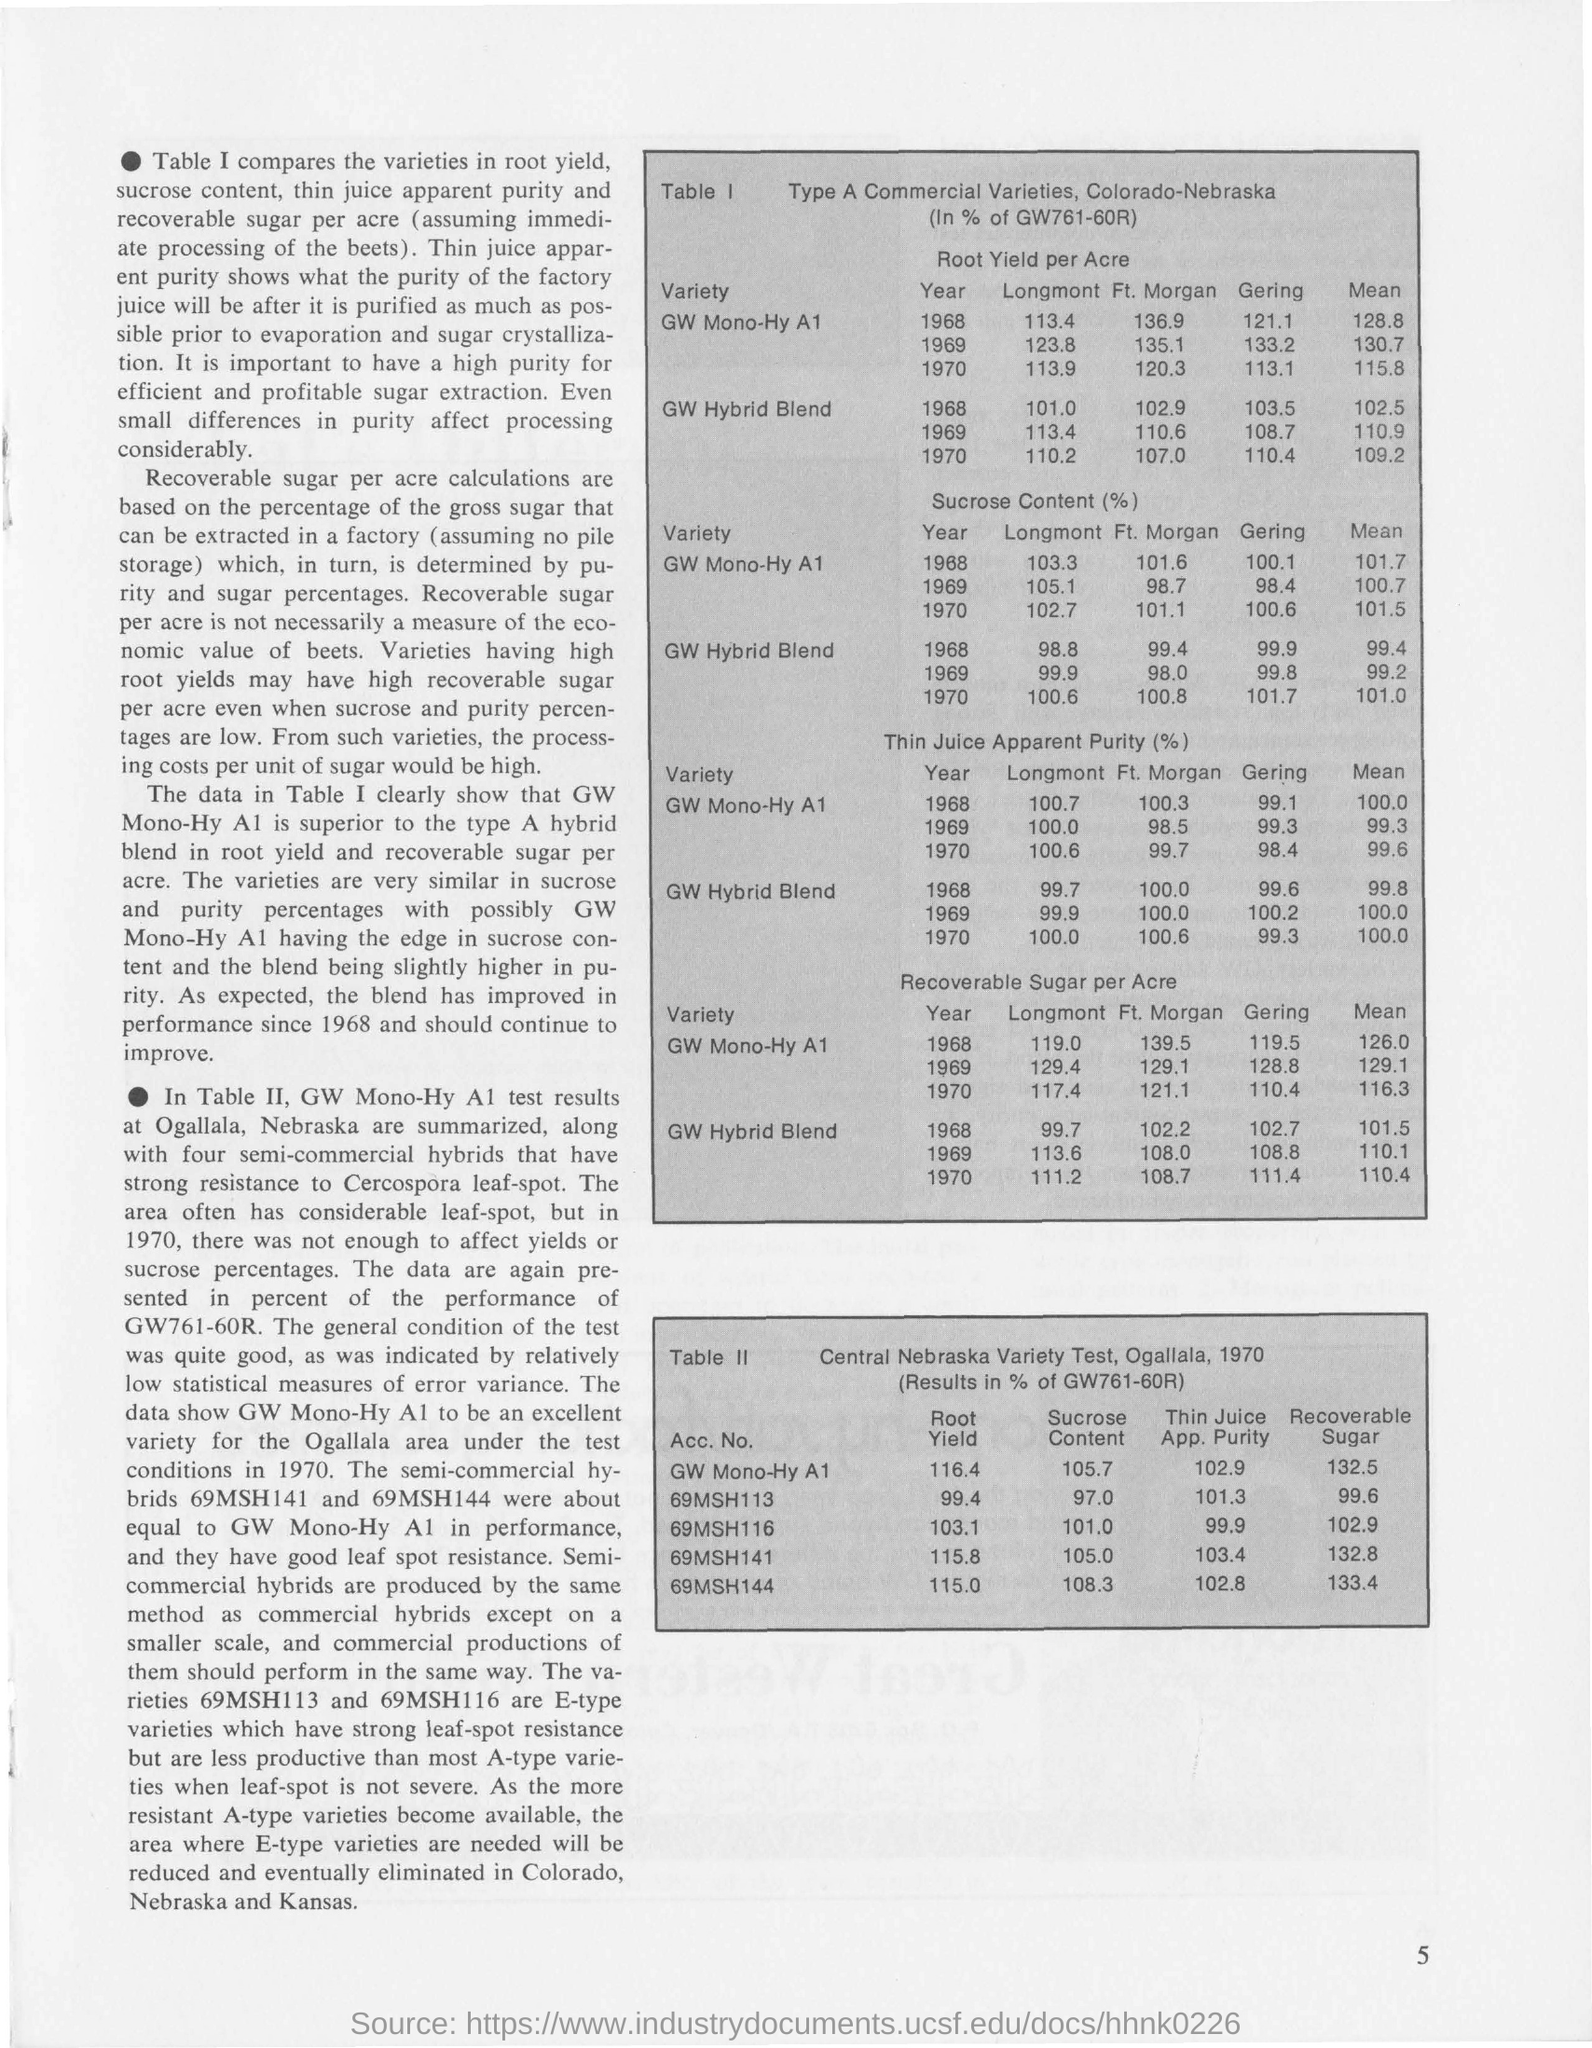What does the Table I show?
Your answer should be compact. Type A Commercial Varieties, Colorado-Nebraska. What does the Table II show?
Give a very brief answer. Central Nebraska Variety Test, Ogallala, 1970. What is the Thin Juice App. Purity of 69MSH144 in Table II?
Offer a terse response. 102.8. What is the Mean of the GW Hybrid Blend by Recoverable sugar per acre in1969 in Table I?
Provide a short and direct response. 110.1. 